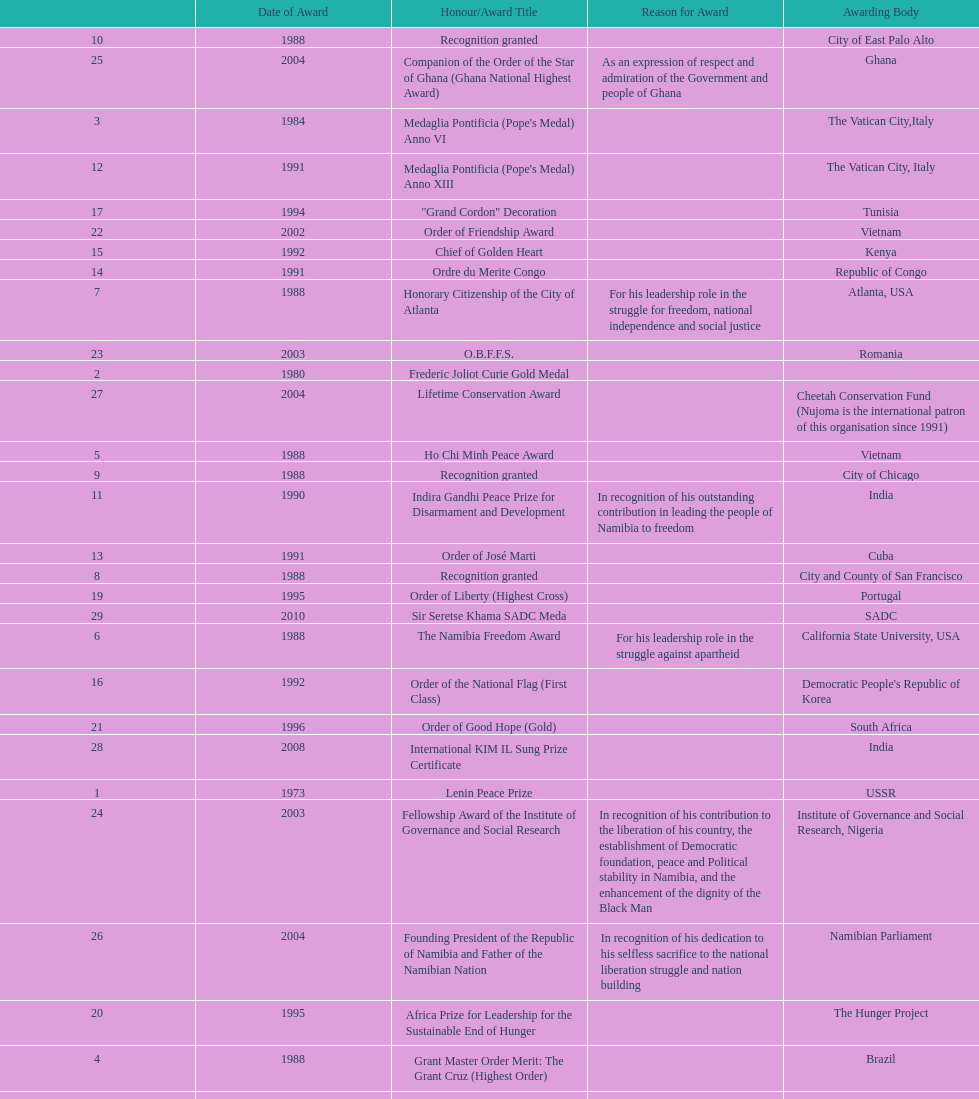What was the name of the honor/award title given after the international kim il sung prize certificate? Sir Seretse Khama SADC Meda. 